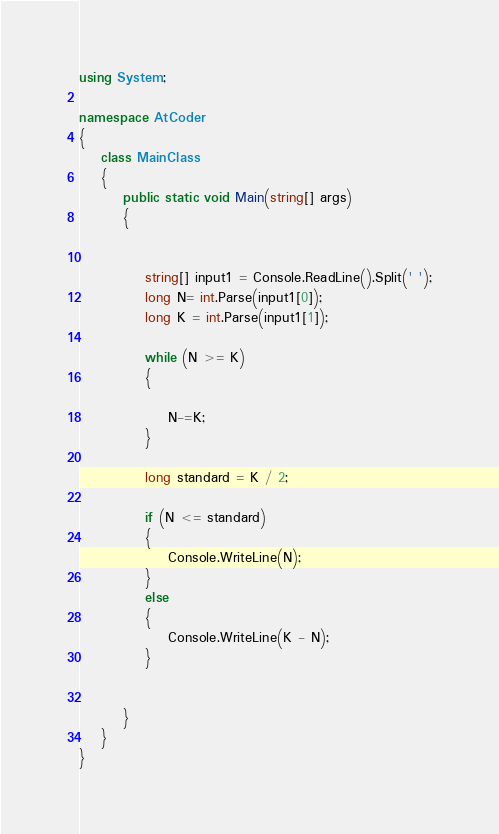Convert code to text. <code><loc_0><loc_0><loc_500><loc_500><_C#_>using System;

namespace AtCoder
{
    class MainClass
    {
        public static void Main(string[] args)
        {
           

            string[] input1 = Console.ReadLine().Split(' ');
            long N= int.Parse(input1[0]);
            long K = int.Parse(input1[1]);

            while (N >= K)
            {

                N-=K;
            }

            long standard = K / 2;

            if (N <= standard)
            {
                Console.WriteLine(N);
            }
            else
            {
                Console.WriteLine(K - N);
            }   

           
        }
    }
}</code> 